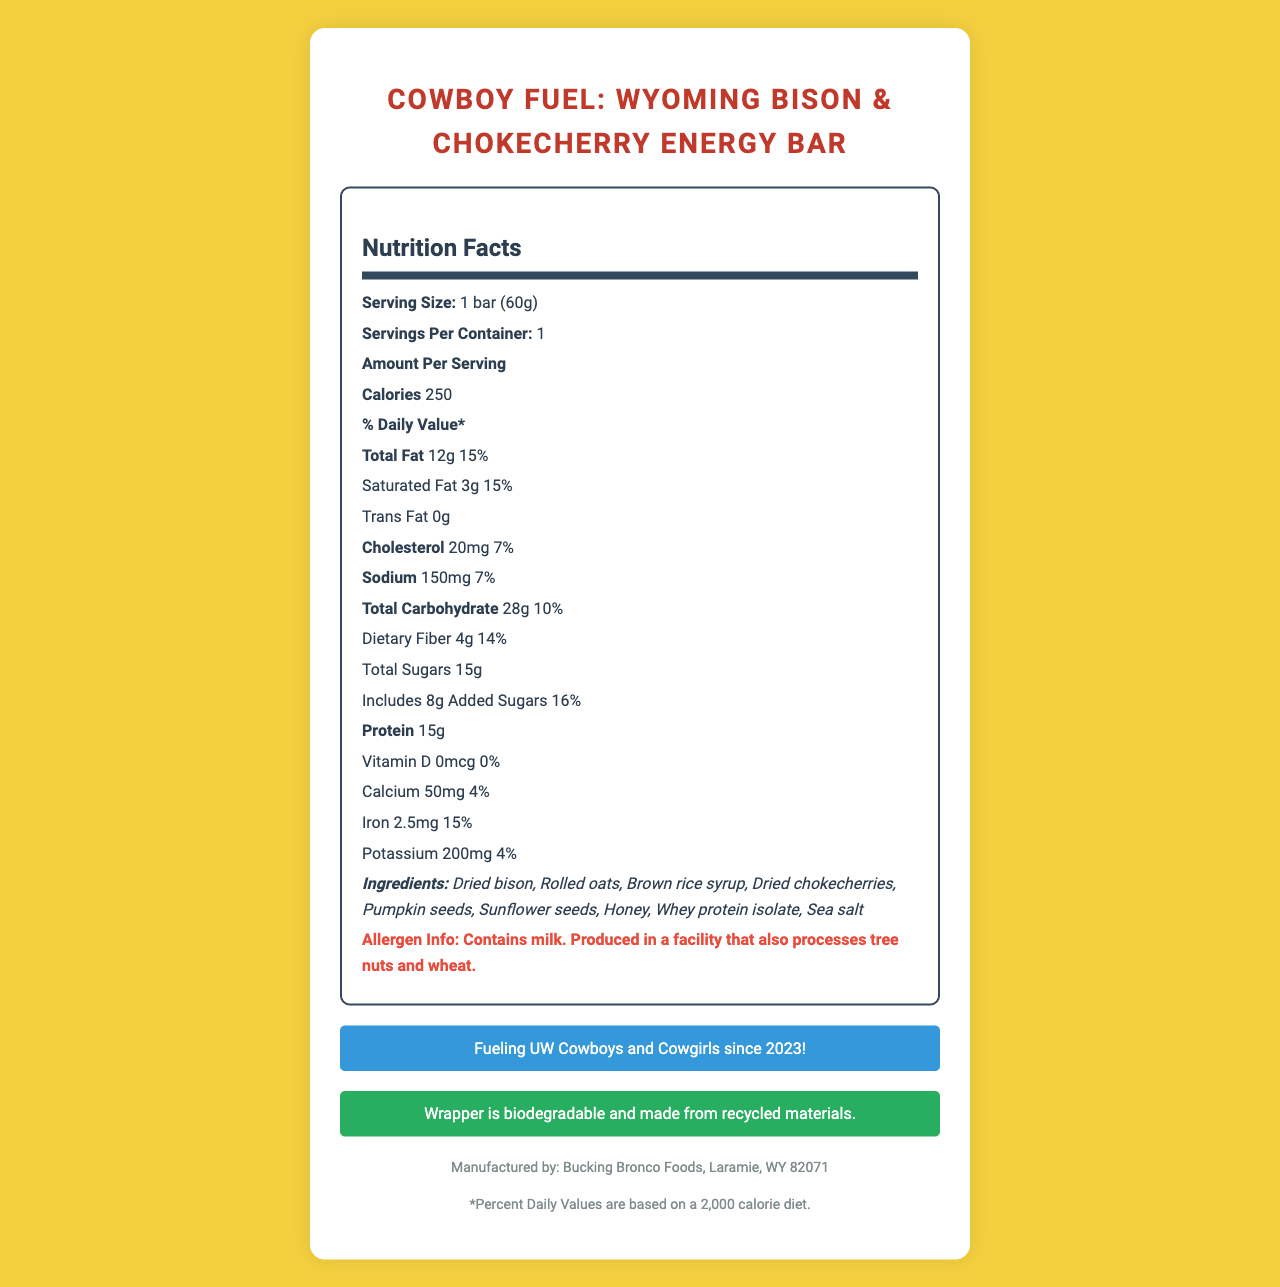what is the serving size? The serving size is clearly listed under the "Serving Size" section of the Nutrition Facts.
Answer: 1 bar (60g) how many grams of protein does one bar contain? The amount of protein per serving is listed as 15g under the "Protein" section.
Answer: 15g how much cholesterol is in one serving? The cholesterol content per serving is specified as 20mg in the Nutrition Facts.
Answer: 20mg what percentage of daily value is provided by the total fat content? The total fat content provides 15% of the daily value, as indicated under "Total Fat".
Answer: 15% which ingredient is not part of the recipe? A. Dried bison B. Rolled oats C. Almonds D. Brown rice syrup The list of ingredients includes dried bison, rolled oats, and brown rice syrup, but not almonds.
Answer: C. Almonds how much dietary fiber is in the energy bar? The amount of dietary fiber is listed as 4g in the Nutrition Facts.
Answer: 4g where is the energy bar manufactured? The manufacturer is listed as "Bucking Bronco Foods, Laramie, WY 82071".
Answer: Laramie, WY 82071 does the product contain any added sugars? The document specifies that it includes 8g of added sugars.
Answer: Yes are there any allergens mentioned in the product? The product contains milk and is produced in a facility that processes tree nuts and wheat.
Answer: Yes summarize the main idea of the document. The document acts as a comprehensive nutritional label for "Cowboy Fuel: Wyoming Bison & Chokecherry Energy Bar", detailing specific data points like calories, fats, sugars, proteins, and dietary fibers, along with additional notes on allergens, sustainability, and manufacturing.
Answer: The document provides the nutritional information for "Cowboy Fuel: Wyoming Bison & Chokecherry Energy Bar", including serving size, calorie count, macronutrients, ingredients, allergen information, manufacturing details, and sustainability notes. how many calories are in the energy bar? The calorie count is prominently listed as 250 in the Nutrition Facts.
Answer: 250 which vitamin is not present in the energy bar? A. Vitamin D B. Calcium C. Iron D. Potassium The Nutrition Facts indicate there is 0mcg of Vitamin D, meaning it is not present in the bar.
Answer: A. Vitamin D what is the percentage of daily value for iron? The daily value percentage for iron is listed as 15%.
Answer: 15% does the document mention any UW-related fact? The document includes a UW Cowboys Fact stating "Fueling UW Cowboys and Cowgirls since 2023!".
Answer: Yes how much sodium does the energy bar contain? The amount of sodium per serving is listed as 150mg.
Answer: 150mg is the wrapper of the energy bar environmentally friendly? The document mentions that the wrapper is biodegradable and made from recycled materials.
Answer: Yes how many total grams of carbohydrates are in the energy bar? The total carbohydrate content per serving is listed as 28g.
Answer: 28g who is the target audience mentioned in the document? The document states that the bar is "Fueling UW Cowboys and Cowgirls since 2023".
Answer: UW Cowboys and Cowgirls how much calcium is provided by the energy bar? The calcium content is listed as 50mg in the Nutrition Facts.
Answer: 50mg who manufactured the energy bar? The manufacturer is listed as Bucking Bronco Foods, Laramie, WY 82071.
Answer: Bucking Bronco Foods what is the price of the energy bar? The document does not provide any information regarding the price of the energy bar.
Answer: Not enough information 